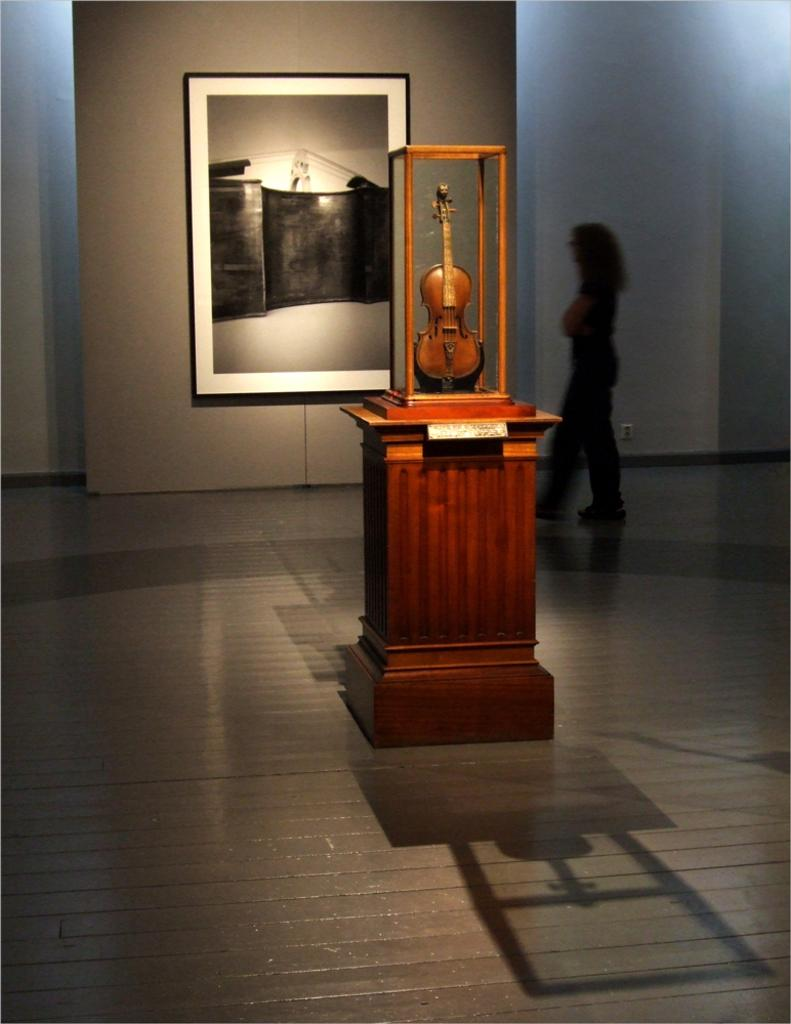What is the main subject of the image? There is a person standing in the image. Where is the person standing? The person is standing on the floor. What object can be seen near the person? There is a guitar in the image. What is the background of the image composed of? There is a wall and a frame in the image. What type of oven can be seen in the image? There is no oven present in the image. How does the frame turn in the image? The frame does not turn in the image; it is stationary. 